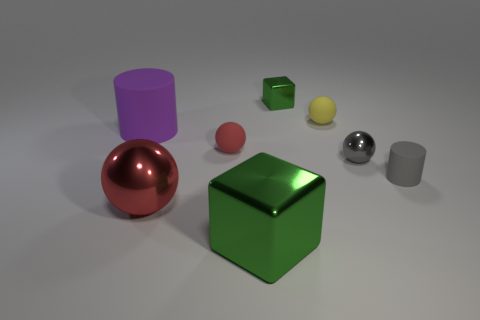What is the color of the big cylinder that is the same material as the tiny yellow ball?
Make the answer very short. Purple. What number of yellow spheres are the same material as the small red object?
Make the answer very short. 1. How many objects are big gray shiny blocks or things that are in front of the small red rubber sphere?
Your response must be concise. 4. Are the red ball on the left side of the tiny red rubber sphere and the gray ball made of the same material?
Your response must be concise. Yes. What color is the block that is the same size as the purple rubber cylinder?
Provide a short and direct response. Green. Is there a purple rubber object that has the same shape as the big green metallic object?
Your answer should be compact. No. There is a ball behind the rubber cylinder left of the green shiny thing that is behind the red metal thing; what color is it?
Your answer should be compact. Yellow. How many matte things are either small red objects or small gray objects?
Keep it short and to the point. 2. Is the number of tiny gray metallic things behind the tiny shiny cube greater than the number of metallic balls that are behind the gray cylinder?
Ensure brevity in your answer.  No. What number of other things are there of the same size as the red rubber object?
Offer a very short reply. 4. 